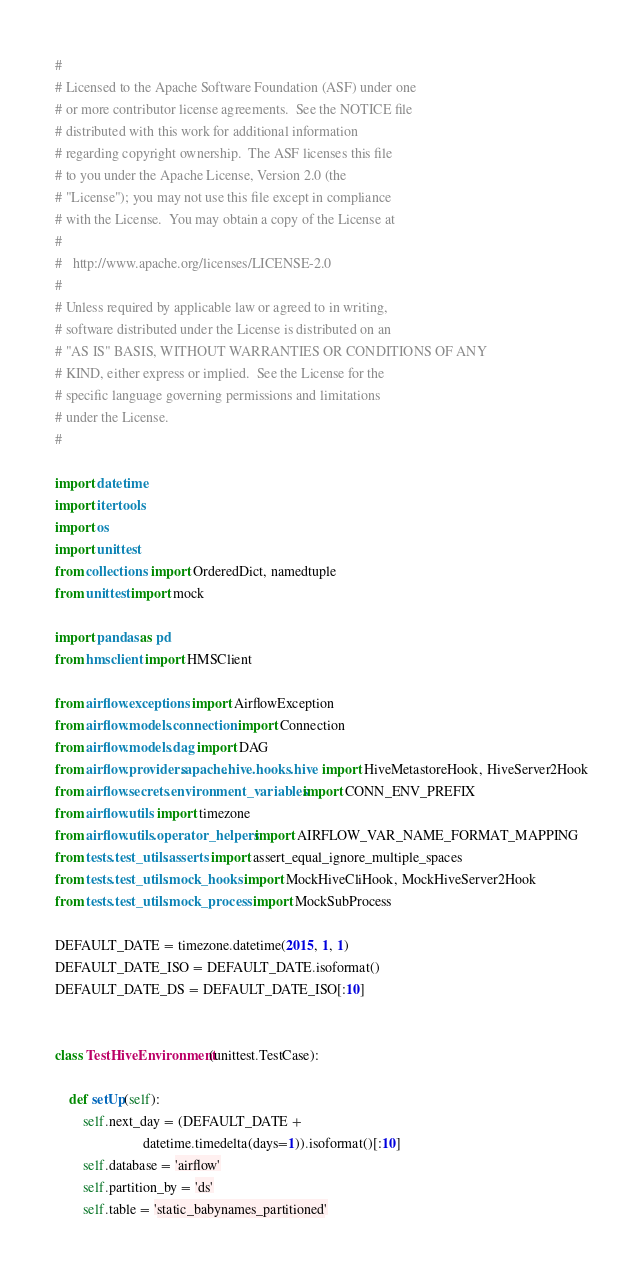Convert code to text. <code><loc_0><loc_0><loc_500><loc_500><_Python_>#
# Licensed to the Apache Software Foundation (ASF) under one
# or more contributor license agreements.  See the NOTICE file
# distributed with this work for additional information
# regarding copyright ownership.  The ASF licenses this file
# to you under the Apache License, Version 2.0 (the
# "License"); you may not use this file except in compliance
# with the License.  You may obtain a copy of the License at
#
#   http://www.apache.org/licenses/LICENSE-2.0
#
# Unless required by applicable law or agreed to in writing,
# software distributed under the License is distributed on an
# "AS IS" BASIS, WITHOUT WARRANTIES OR CONDITIONS OF ANY
# KIND, either express or implied.  See the License for the
# specific language governing permissions and limitations
# under the License.
#

import datetime
import itertools
import os
import unittest
from collections import OrderedDict, namedtuple
from unittest import mock

import pandas as pd
from hmsclient import HMSClient

from airflow.exceptions import AirflowException
from airflow.models.connection import Connection
from airflow.models.dag import DAG
from airflow.providers.apache.hive.hooks.hive import HiveMetastoreHook, HiveServer2Hook
from airflow.secrets.environment_variables import CONN_ENV_PREFIX
from airflow.utils import timezone
from airflow.utils.operator_helpers import AIRFLOW_VAR_NAME_FORMAT_MAPPING
from tests.test_utils.asserts import assert_equal_ignore_multiple_spaces
from tests.test_utils.mock_hooks import MockHiveCliHook, MockHiveServer2Hook
from tests.test_utils.mock_process import MockSubProcess

DEFAULT_DATE = timezone.datetime(2015, 1, 1)
DEFAULT_DATE_ISO = DEFAULT_DATE.isoformat()
DEFAULT_DATE_DS = DEFAULT_DATE_ISO[:10]


class TestHiveEnvironment(unittest.TestCase):

    def setUp(self):
        self.next_day = (DEFAULT_DATE +
                         datetime.timedelta(days=1)).isoformat()[:10]
        self.database = 'airflow'
        self.partition_by = 'ds'
        self.table = 'static_babynames_partitioned'</code> 